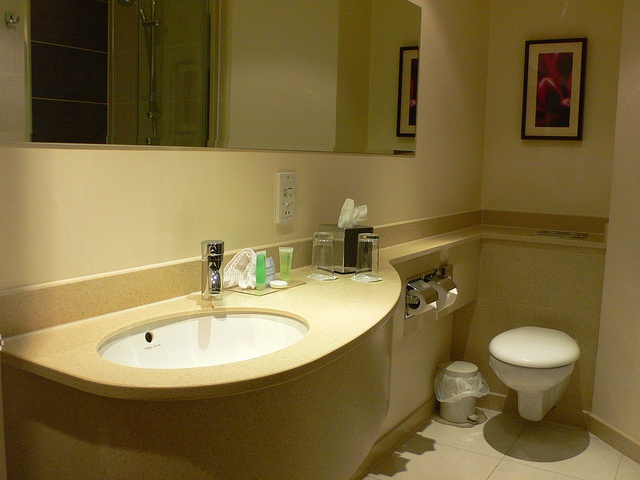Describe the objects in this image and their specific colors. I can see sink in olive, beige, and tan tones, toilet in olive, beige, and gray tones, cup in olive and black tones, cup in olive and gray tones, and cup in olive and khaki tones in this image. 